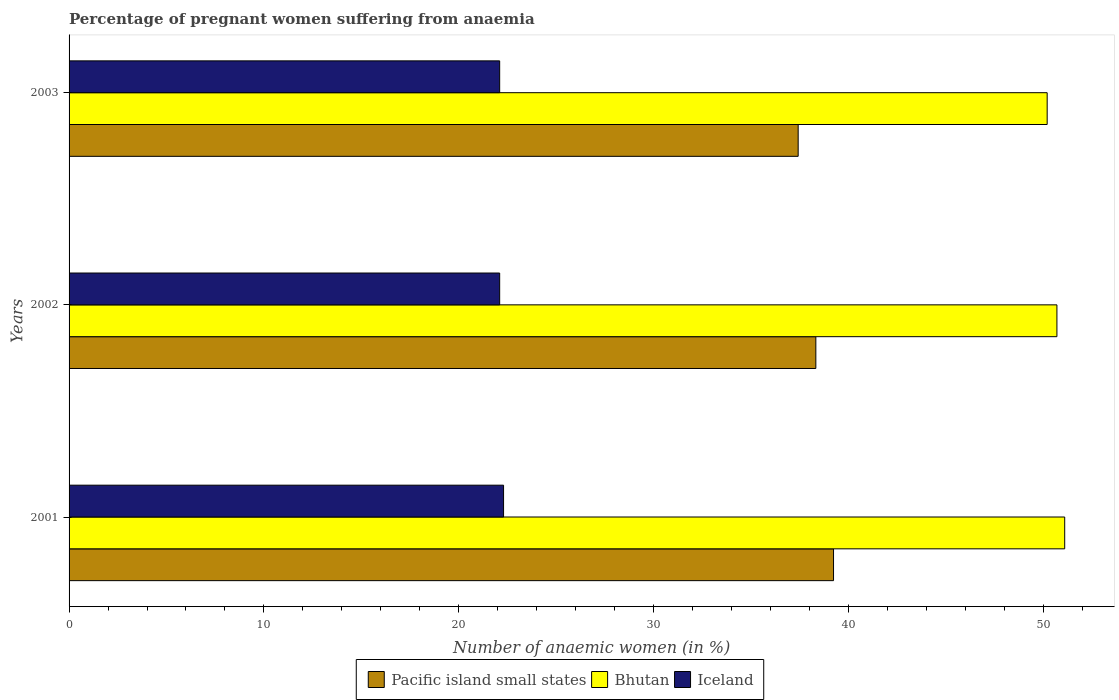How many different coloured bars are there?
Your response must be concise. 3. How many groups of bars are there?
Your answer should be compact. 3. Are the number of bars per tick equal to the number of legend labels?
Provide a succinct answer. Yes. How many bars are there on the 2nd tick from the top?
Offer a terse response. 3. How many bars are there on the 3rd tick from the bottom?
Offer a very short reply. 3. What is the number of anaemic women in Iceland in 2002?
Your answer should be very brief. 22.1. Across all years, what is the maximum number of anaemic women in Iceland?
Your answer should be very brief. 22.3. Across all years, what is the minimum number of anaemic women in Pacific island small states?
Offer a very short reply. 37.42. What is the total number of anaemic women in Iceland in the graph?
Keep it short and to the point. 66.5. What is the difference between the number of anaemic women in Bhutan in 2001 and that in 2003?
Provide a succinct answer. 0.9. What is the difference between the number of anaemic women in Pacific island small states in 2003 and the number of anaemic women in Bhutan in 2002?
Give a very brief answer. -13.28. What is the average number of anaemic women in Bhutan per year?
Give a very brief answer. 50.67. In the year 2002, what is the difference between the number of anaemic women in Pacific island small states and number of anaemic women in Bhutan?
Provide a short and direct response. -12.37. What is the ratio of the number of anaemic women in Bhutan in 2001 to that in 2003?
Offer a very short reply. 1.02. Is the difference between the number of anaemic women in Pacific island small states in 2002 and 2003 greater than the difference between the number of anaemic women in Bhutan in 2002 and 2003?
Give a very brief answer. Yes. What is the difference between the highest and the second highest number of anaemic women in Bhutan?
Provide a short and direct response. 0.4. What is the difference between the highest and the lowest number of anaemic women in Bhutan?
Make the answer very short. 0.9. Is the sum of the number of anaemic women in Iceland in 2001 and 2003 greater than the maximum number of anaemic women in Pacific island small states across all years?
Make the answer very short. Yes. What does the 3rd bar from the top in 2003 represents?
Ensure brevity in your answer.  Pacific island small states. Is it the case that in every year, the sum of the number of anaemic women in Bhutan and number of anaemic women in Pacific island small states is greater than the number of anaemic women in Iceland?
Your answer should be compact. Yes. How many bars are there?
Your answer should be compact. 9. How many years are there in the graph?
Your response must be concise. 3. Are the values on the major ticks of X-axis written in scientific E-notation?
Offer a very short reply. No. Does the graph contain grids?
Ensure brevity in your answer.  No. What is the title of the graph?
Provide a succinct answer. Percentage of pregnant women suffering from anaemia. What is the label or title of the X-axis?
Make the answer very short. Number of anaemic women (in %). What is the label or title of the Y-axis?
Offer a very short reply. Years. What is the Number of anaemic women (in %) of Pacific island small states in 2001?
Keep it short and to the point. 39.23. What is the Number of anaemic women (in %) of Bhutan in 2001?
Ensure brevity in your answer.  51.1. What is the Number of anaemic women (in %) of Iceland in 2001?
Your response must be concise. 22.3. What is the Number of anaemic women (in %) of Pacific island small states in 2002?
Your response must be concise. 38.33. What is the Number of anaemic women (in %) in Bhutan in 2002?
Your answer should be compact. 50.7. What is the Number of anaemic women (in %) in Iceland in 2002?
Provide a succinct answer. 22.1. What is the Number of anaemic women (in %) of Pacific island small states in 2003?
Offer a terse response. 37.42. What is the Number of anaemic women (in %) of Bhutan in 2003?
Ensure brevity in your answer.  50.2. What is the Number of anaemic women (in %) of Iceland in 2003?
Offer a terse response. 22.1. Across all years, what is the maximum Number of anaemic women (in %) of Pacific island small states?
Ensure brevity in your answer.  39.23. Across all years, what is the maximum Number of anaemic women (in %) in Bhutan?
Give a very brief answer. 51.1. Across all years, what is the maximum Number of anaemic women (in %) in Iceland?
Give a very brief answer. 22.3. Across all years, what is the minimum Number of anaemic women (in %) in Pacific island small states?
Your response must be concise. 37.42. Across all years, what is the minimum Number of anaemic women (in %) of Bhutan?
Your response must be concise. 50.2. Across all years, what is the minimum Number of anaemic women (in %) in Iceland?
Provide a succinct answer. 22.1. What is the total Number of anaemic women (in %) in Pacific island small states in the graph?
Keep it short and to the point. 114.98. What is the total Number of anaemic women (in %) in Bhutan in the graph?
Provide a short and direct response. 152. What is the total Number of anaemic women (in %) of Iceland in the graph?
Provide a succinct answer. 66.5. What is the difference between the Number of anaemic women (in %) in Pacific island small states in 2001 and that in 2002?
Offer a very short reply. 0.91. What is the difference between the Number of anaemic women (in %) of Pacific island small states in 2001 and that in 2003?
Give a very brief answer. 1.81. What is the difference between the Number of anaemic women (in %) of Pacific island small states in 2002 and that in 2003?
Offer a terse response. 0.91. What is the difference between the Number of anaemic women (in %) in Pacific island small states in 2001 and the Number of anaemic women (in %) in Bhutan in 2002?
Make the answer very short. -11.47. What is the difference between the Number of anaemic women (in %) of Pacific island small states in 2001 and the Number of anaemic women (in %) of Iceland in 2002?
Ensure brevity in your answer.  17.13. What is the difference between the Number of anaemic women (in %) of Pacific island small states in 2001 and the Number of anaemic women (in %) of Bhutan in 2003?
Give a very brief answer. -10.97. What is the difference between the Number of anaemic women (in %) in Pacific island small states in 2001 and the Number of anaemic women (in %) in Iceland in 2003?
Provide a succinct answer. 17.13. What is the difference between the Number of anaemic women (in %) of Pacific island small states in 2002 and the Number of anaemic women (in %) of Bhutan in 2003?
Your answer should be very brief. -11.87. What is the difference between the Number of anaemic women (in %) of Pacific island small states in 2002 and the Number of anaemic women (in %) of Iceland in 2003?
Give a very brief answer. 16.23. What is the difference between the Number of anaemic women (in %) of Bhutan in 2002 and the Number of anaemic women (in %) of Iceland in 2003?
Ensure brevity in your answer.  28.6. What is the average Number of anaemic women (in %) of Pacific island small states per year?
Your response must be concise. 38.33. What is the average Number of anaemic women (in %) in Bhutan per year?
Offer a terse response. 50.67. What is the average Number of anaemic women (in %) of Iceland per year?
Give a very brief answer. 22.17. In the year 2001, what is the difference between the Number of anaemic women (in %) of Pacific island small states and Number of anaemic women (in %) of Bhutan?
Your answer should be very brief. -11.87. In the year 2001, what is the difference between the Number of anaemic women (in %) in Pacific island small states and Number of anaemic women (in %) in Iceland?
Offer a terse response. 16.93. In the year 2001, what is the difference between the Number of anaemic women (in %) of Bhutan and Number of anaemic women (in %) of Iceland?
Offer a very short reply. 28.8. In the year 2002, what is the difference between the Number of anaemic women (in %) in Pacific island small states and Number of anaemic women (in %) in Bhutan?
Your answer should be compact. -12.37. In the year 2002, what is the difference between the Number of anaemic women (in %) in Pacific island small states and Number of anaemic women (in %) in Iceland?
Provide a short and direct response. 16.23. In the year 2002, what is the difference between the Number of anaemic women (in %) of Bhutan and Number of anaemic women (in %) of Iceland?
Make the answer very short. 28.6. In the year 2003, what is the difference between the Number of anaemic women (in %) of Pacific island small states and Number of anaemic women (in %) of Bhutan?
Provide a short and direct response. -12.78. In the year 2003, what is the difference between the Number of anaemic women (in %) of Pacific island small states and Number of anaemic women (in %) of Iceland?
Provide a succinct answer. 15.32. In the year 2003, what is the difference between the Number of anaemic women (in %) in Bhutan and Number of anaemic women (in %) in Iceland?
Give a very brief answer. 28.1. What is the ratio of the Number of anaemic women (in %) of Pacific island small states in 2001 to that in 2002?
Your answer should be compact. 1.02. What is the ratio of the Number of anaemic women (in %) in Bhutan in 2001 to that in 2002?
Give a very brief answer. 1.01. What is the ratio of the Number of anaemic women (in %) of Iceland in 2001 to that in 2002?
Make the answer very short. 1.01. What is the ratio of the Number of anaemic women (in %) in Pacific island small states in 2001 to that in 2003?
Your answer should be compact. 1.05. What is the ratio of the Number of anaemic women (in %) of Bhutan in 2001 to that in 2003?
Offer a terse response. 1.02. What is the ratio of the Number of anaemic women (in %) in Pacific island small states in 2002 to that in 2003?
Offer a terse response. 1.02. What is the ratio of the Number of anaemic women (in %) in Bhutan in 2002 to that in 2003?
Offer a terse response. 1.01. What is the difference between the highest and the second highest Number of anaemic women (in %) of Pacific island small states?
Provide a succinct answer. 0.91. What is the difference between the highest and the second highest Number of anaemic women (in %) in Bhutan?
Your answer should be compact. 0.4. What is the difference between the highest and the second highest Number of anaemic women (in %) of Iceland?
Your answer should be very brief. 0.2. What is the difference between the highest and the lowest Number of anaemic women (in %) in Pacific island small states?
Your answer should be compact. 1.81. What is the difference between the highest and the lowest Number of anaemic women (in %) in Bhutan?
Your answer should be very brief. 0.9. 